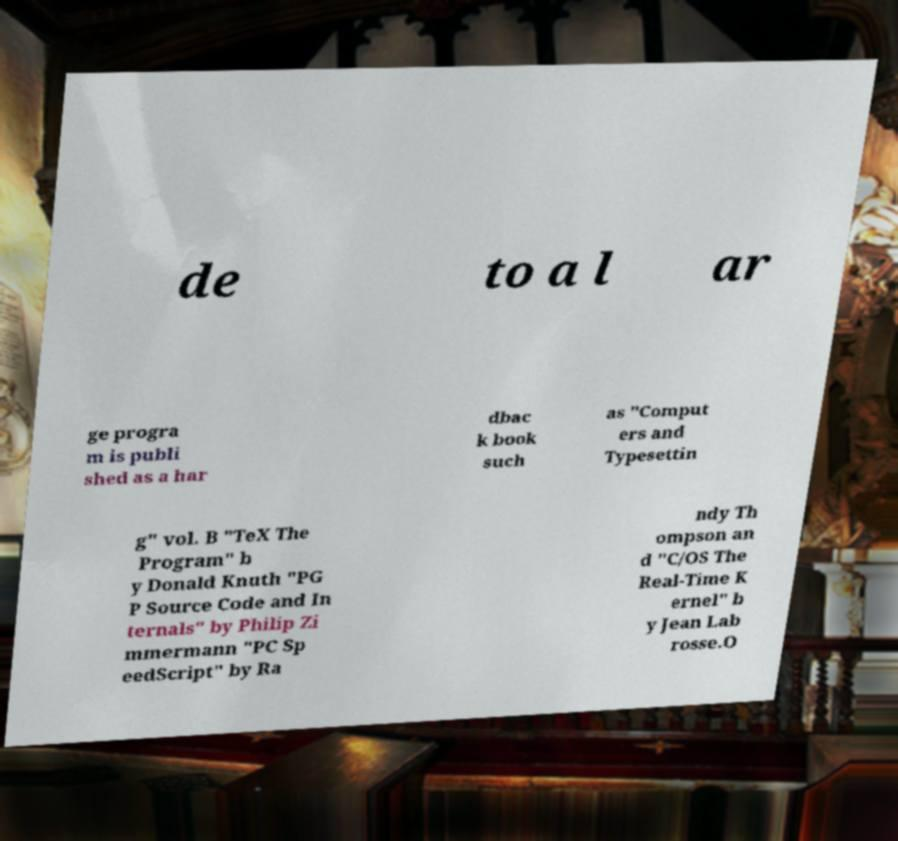Please read and relay the text visible in this image. What does it say? de to a l ar ge progra m is publi shed as a har dbac k book such as "Comput ers and Typesettin g" vol. B "TeX The Program" b y Donald Knuth "PG P Source Code and In ternals" by Philip Zi mmermann "PC Sp eedScript" by Ra ndy Th ompson an d "C/OS The Real-Time K ernel" b y Jean Lab rosse.O 